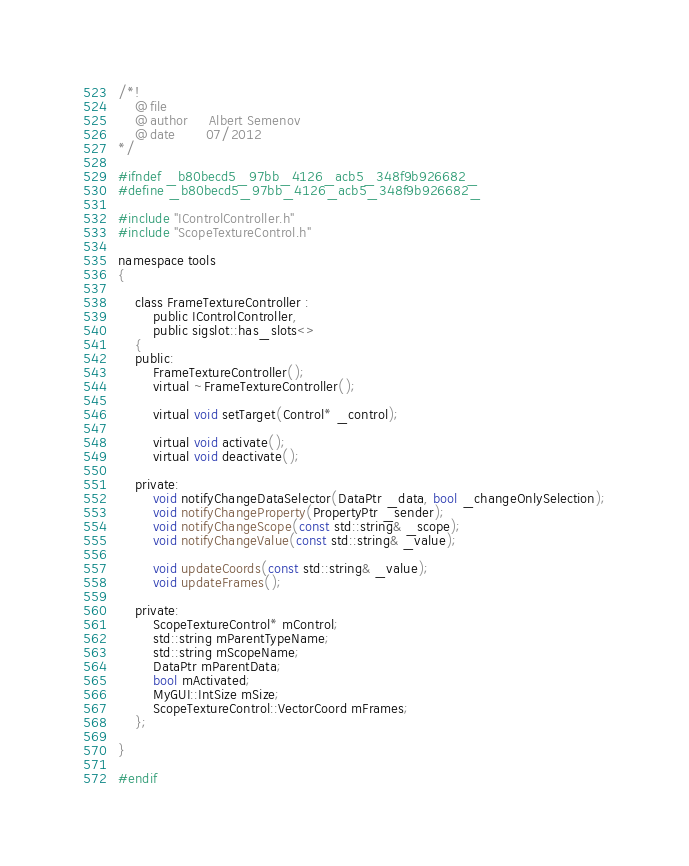<code> <loc_0><loc_0><loc_500><loc_500><_C_>/*!
	@file
	@author		Albert Semenov
	@date		07/2012
*/

#ifndef _b80becd5_97bb_4126_acb5_348f9b926682_
#define _b80becd5_97bb_4126_acb5_348f9b926682_

#include "IControlController.h"
#include "ScopeTextureControl.h"

namespace tools
{

	class FrameTextureController :
		public IControlController,
		public sigslot::has_slots<>
	{
	public:
		FrameTextureController();
		virtual ~FrameTextureController();

		virtual void setTarget(Control* _control);

		virtual void activate();
		virtual void deactivate();

	private:
		void notifyChangeDataSelector(DataPtr _data, bool _changeOnlySelection);
		void notifyChangeProperty(PropertyPtr _sender);
		void notifyChangeScope(const std::string& _scope);
		void notifyChangeValue(const std::string& _value);

		void updateCoords(const std::string& _value);
		void updateFrames();

	private:
		ScopeTextureControl* mControl;
		std::string mParentTypeName;
		std::string mScopeName;
		DataPtr mParentData;
		bool mActivated;
		MyGUI::IntSize mSize;
		ScopeTextureControl::VectorCoord mFrames;
	};

}

#endif
</code> 